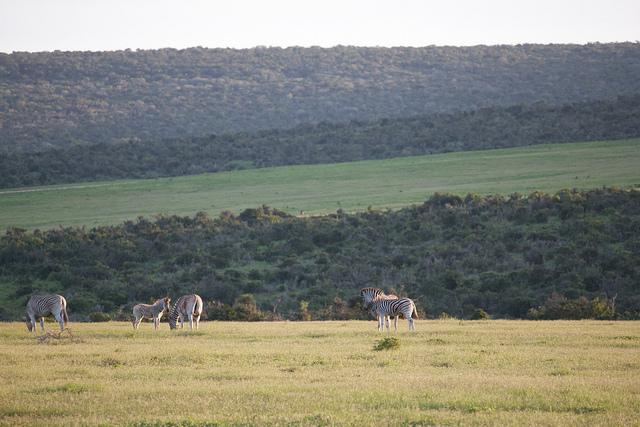How many zebras are sitting atop of the grassy field? Please explain your reasoning. four. As long as you can count, you can see how many zebra's are on the field. 